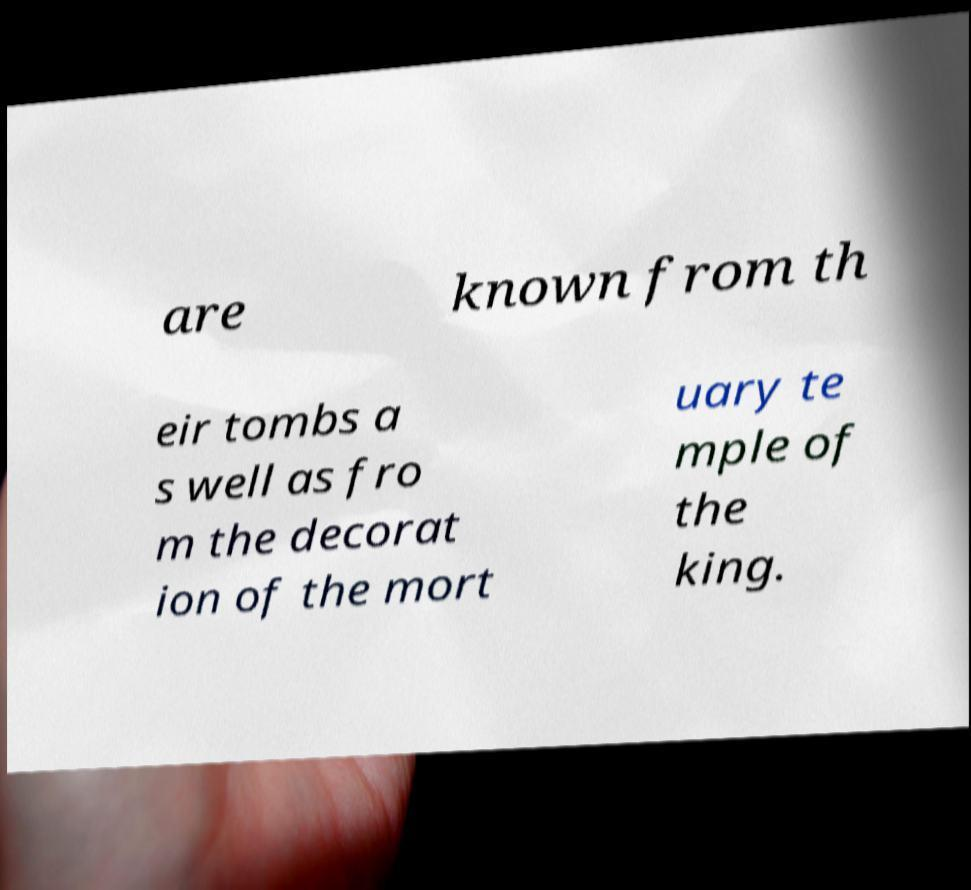Could you assist in decoding the text presented in this image and type it out clearly? are known from th eir tombs a s well as fro m the decorat ion of the mort uary te mple of the king. 